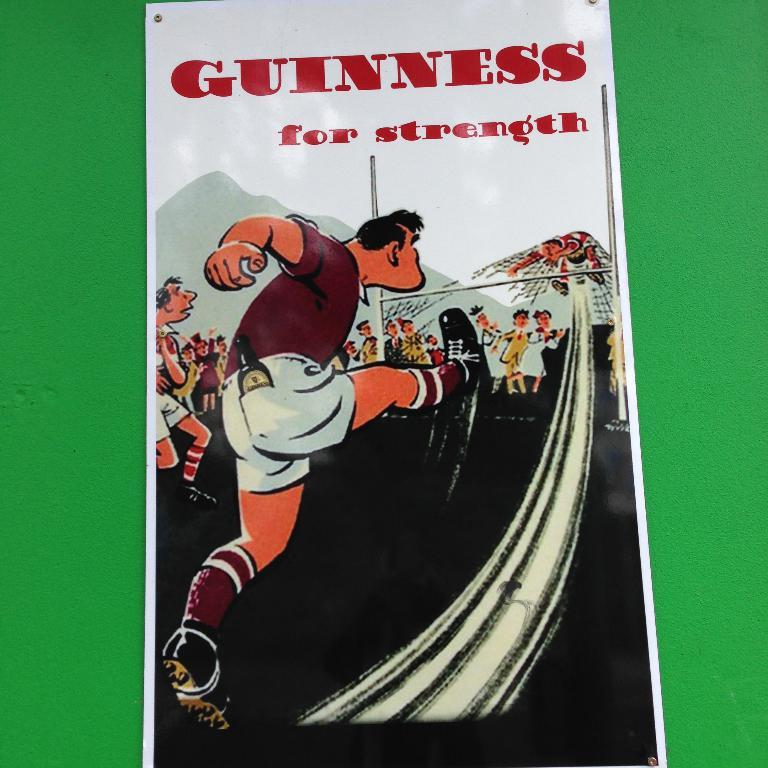Provide a one-sentence caption for the provided image. A man kicks a ball into a goalies stomach under the words Guinness For Strength. 